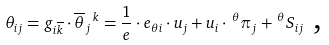Convert formula to latex. <formula><loc_0><loc_0><loc_500><loc_500>\theta _ { i j } = g _ { i \overline { k } } \cdot \overline { \theta } _ { j } \, ^ { k } = \frac { 1 } { e } \cdot e _ { \theta i } \cdot u _ { j } + u _ { i } \cdot \, ^ { \theta } \pi _ { j } + \, ^ { \theta } S _ { i j } \text { ,}</formula> 